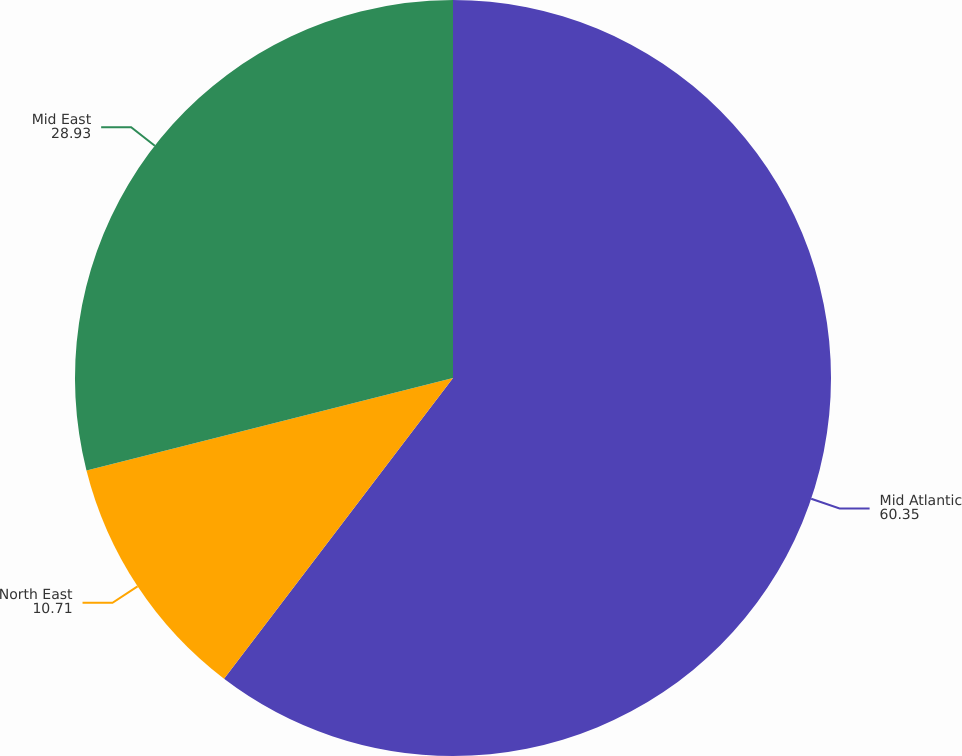Convert chart. <chart><loc_0><loc_0><loc_500><loc_500><pie_chart><fcel>Mid Atlantic<fcel>North East<fcel>Mid East<nl><fcel>60.35%<fcel>10.71%<fcel>28.93%<nl></chart> 